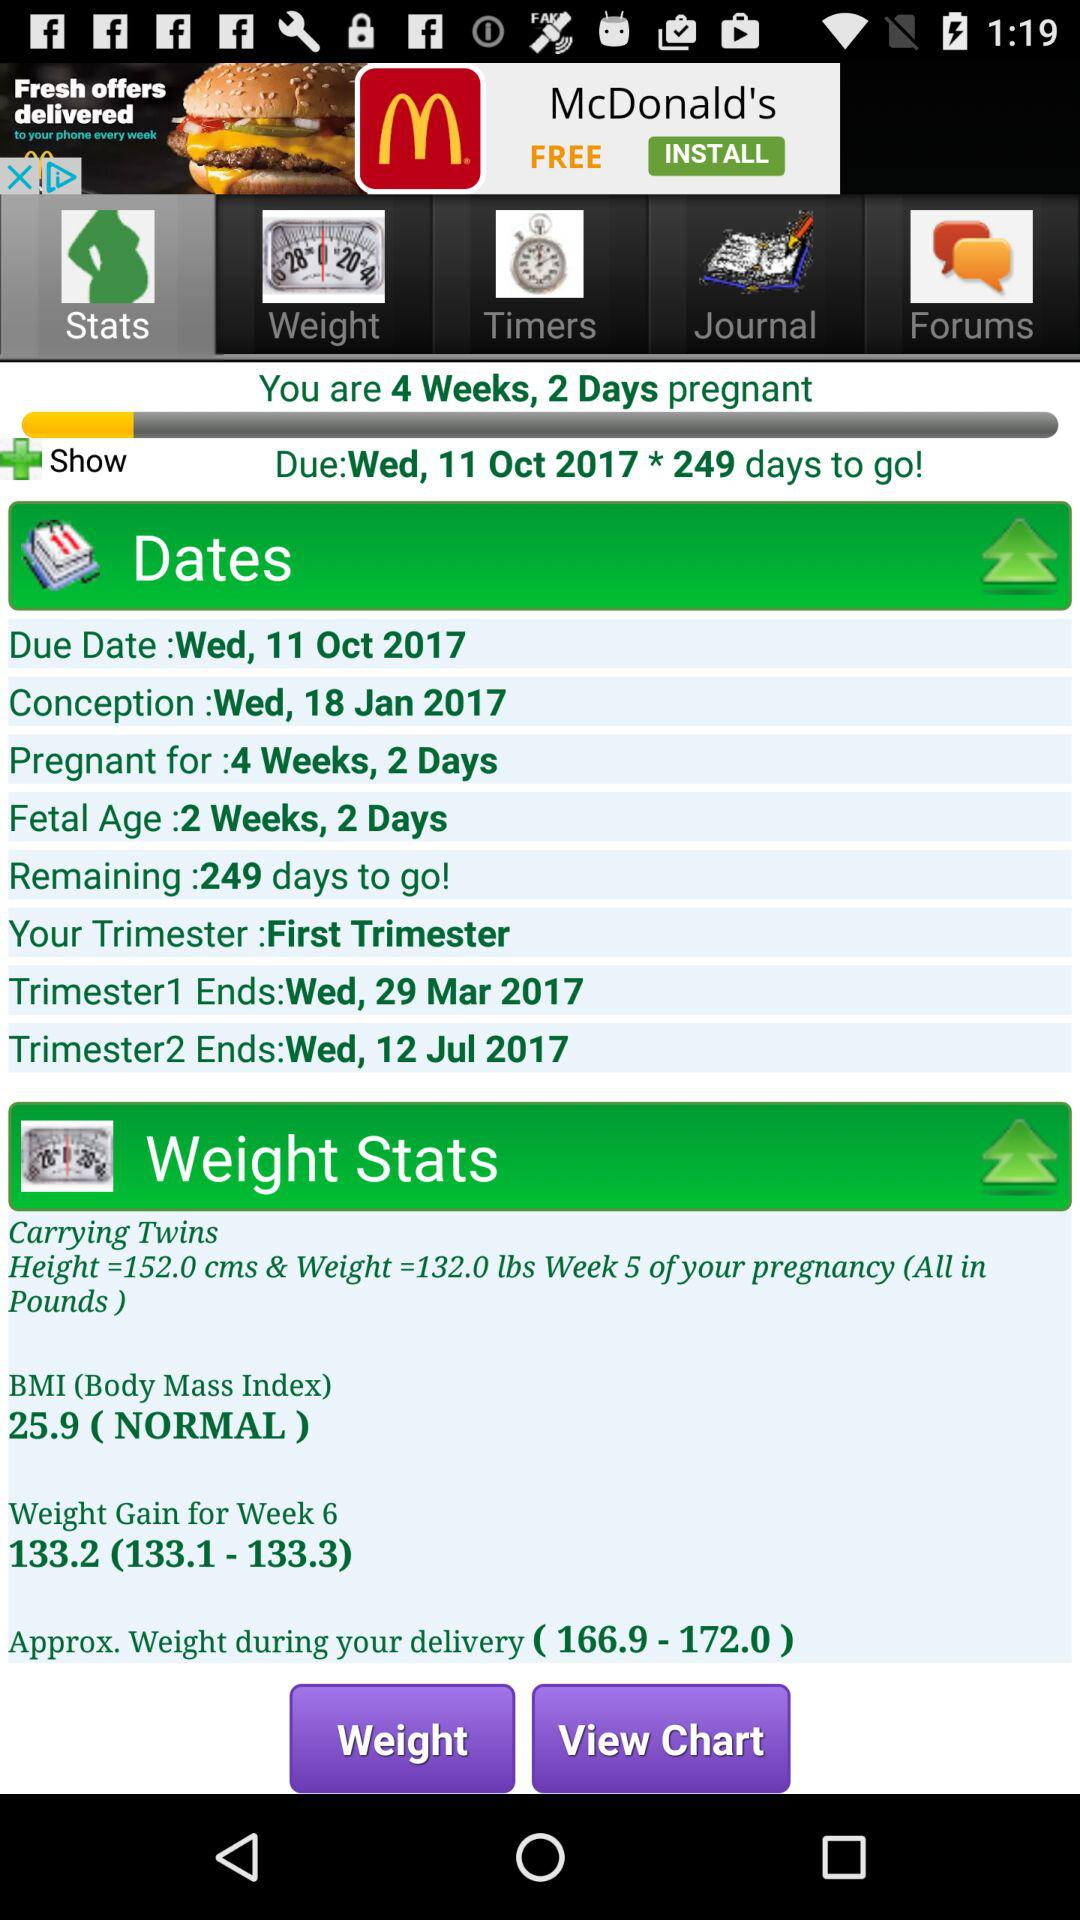How many remaining days to go? The remaining days are 249. 